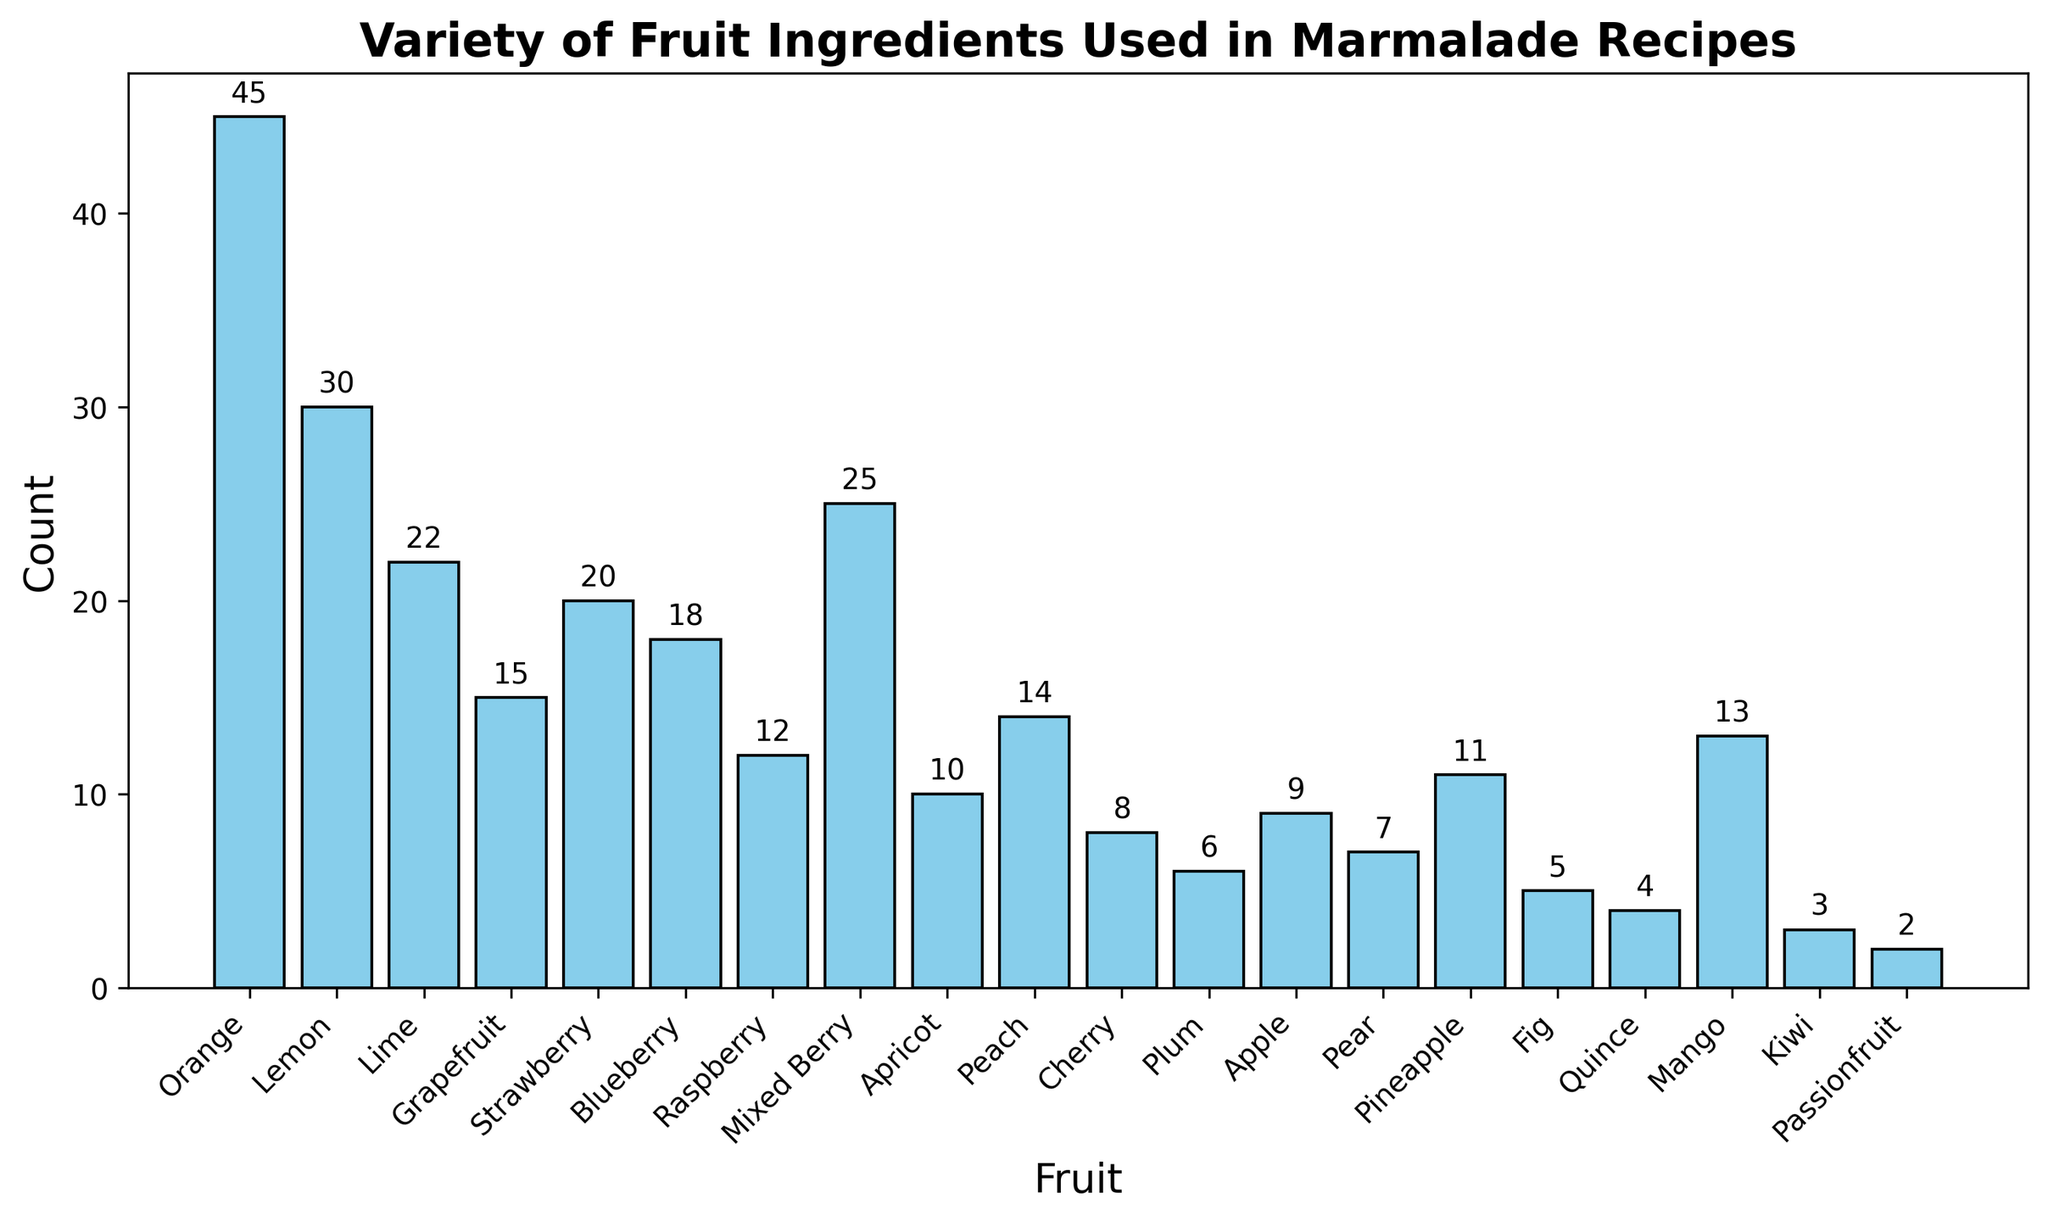What is the most frequently used fruit ingredient for marmalade? The figure shows bars representing different fruit ingredients along with their counts. Orange has the highest bar with a count of 45.
Answer: Orange Which fruit ingredient has the lowest usage count in the marmalade recipes? By observing the heights of the bars, the Kiwi bar is the shortest with a count of 3.
Answer: Kiwi How many more times is Orange used than Quince in marmalade recipes? From the figure, Orange has a count of 45 and Quince has a count of 4. The difference is 45 - 4 = 41.
Answer: 41 What is the sum of the counts for Berry ingredients (Strawberry, Blueberry, Raspberry, Mixed Berry)? The counts are Strawberry (20), Blueberry (18), Raspberry (12), and Mixed Berry (25). Adding them gives 20 + 18 + 12 + 25 = 75.
Answer: 75 Which fruit ingredient is used less often, Cherry or Passionfruit? The bars for Cherry and Passionfruit show counts of 8 and 2, respectively. Passionfruit is used less often.
Answer: Passionfruit What is the average count of the top three most used fruit ingredients? The top three fruit ingredients are Orange (45), Lemon (30), and Mixed Berry (25). Their average is (45 + 30 + 25) / 3 = 100 / 3 ≈ 33.33.
Answer: 33.33 How many fruit ingredients have a usage count below 10? By counting the bars with heights below 10, there are Plum (6), Apple (9), Pear (7), Pineapple (11), Fig (5), Quince (4), Mango (13), Kiwi (3), and Passionfruit (2). There are 8 fruits with counts below 10.
Answer: 8 Is the number of recipes with Apricot more than twice that with Fig? Apricot has a count of 10, while Fig has a count of 5. Since 10 is exactly twice 5, it is not more than twice.
Answer: No Which fruit's count is closest to the median count of all fruits? Sorting the counts gives: [2, 3, 4, 5, 6, 7, 8, 9, 10, 11, 12, 13, 14, 15, 18, 20, 22, 25, 30, 45]. The median count (10th and 11th value) is (11+12)/2 = 11.5, and Pineapple has a count of 11, closest to it.
Answer: Pineapple 